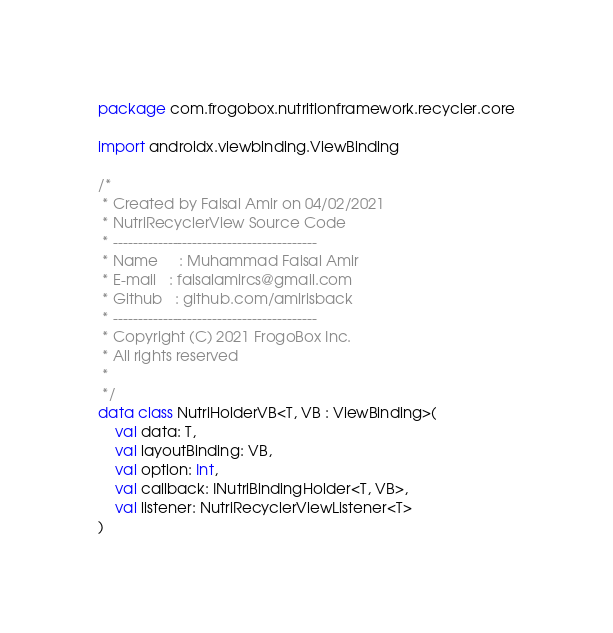Convert code to text. <code><loc_0><loc_0><loc_500><loc_500><_Kotlin_>package com.frogobox.nutritionframework.recycler.core

import androidx.viewbinding.ViewBinding

/*
 * Created by Faisal Amir on 04/02/2021
 * NutriRecyclerView Source Code
 * -----------------------------------------
 * Name     : Muhammad Faisal Amir
 * E-mail   : faisalamircs@gmail.com
 * Github   : github.com/amirisback
 * -----------------------------------------
 * Copyright (C) 2021 FrogoBox Inc.      
 * All rights reserved
 *
 */
data class NutriHolderVB<T, VB : ViewBinding>(
    val data: T,
    val layoutBinding: VB,
    val option: Int,
    val callback: INutriBindingHolder<T, VB>,
    val listener: NutriRecyclerViewListener<T>
)</code> 